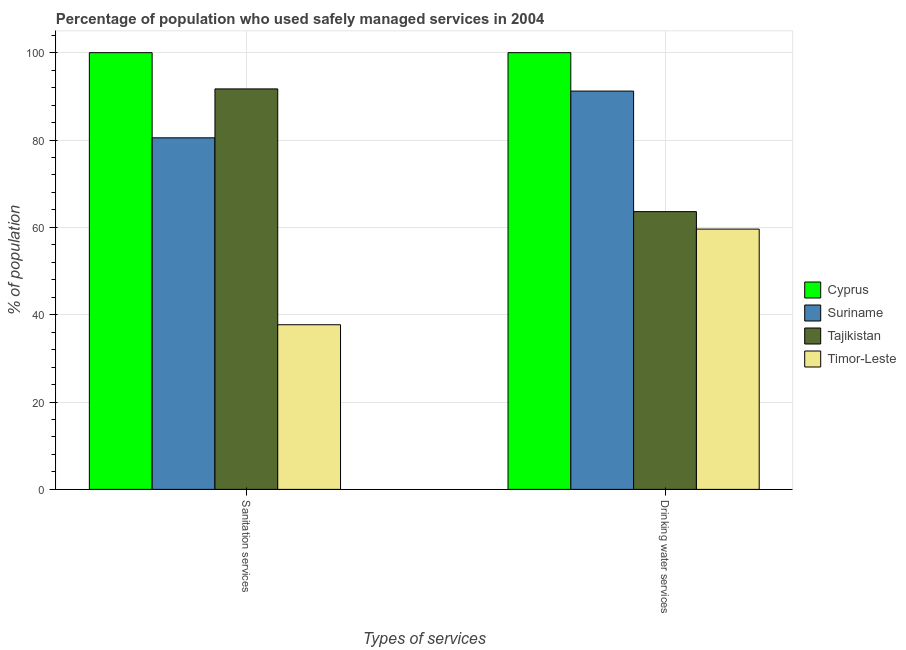How many groups of bars are there?
Your answer should be very brief. 2. Are the number of bars on each tick of the X-axis equal?
Give a very brief answer. Yes. What is the label of the 1st group of bars from the left?
Offer a terse response. Sanitation services. What is the percentage of population who used drinking water services in Timor-Leste?
Offer a terse response. 59.6. Across all countries, what is the minimum percentage of population who used sanitation services?
Make the answer very short. 37.7. In which country was the percentage of population who used drinking water services maximum?
Provide a succinct answer. Cyprus. In which country was the percentage of population who used sanitation services minimum?
Make the answer very short. Timor-Leste. What is the total percentage of population who used drinking water services in the graph?
Offer a terse response. 314.4. What is the difference between the percentage of population who used drinking water services in Tajikistan and that in Suriname?
Your answer should be compact. -27.6. What is the difference between the percentage of population who used sanitation services in Timor-Leste and the percentage of population who used drinking water services in Tajikistan?
Provide a short and direct response. -25.9. What is the average percentage of population who used drinking water services per country?
Your answer should be compact. 78.6. What is the difference between the percentage of population who used sanitation services and percentage of population who used drinking water services in Timor-Leste?
Your answer should be very brief. -21.9. In how many countries, is the percentage of population who used sanitation services greater than 12 %?
Make the answer very short. 4. What is the ratio of the percentage of population who used drinking water services in Tajikistan to that in Suriname?
Offer a terse response. 0.7. What does the 1st bar from the left in Drinking water services represents?
Ensure brevity in your answer.  Cyprus. What does the 1st bar from the right in Sanitation services represents?
Your answer should be compact. Timor-Leste. How many bars are there?
Your response must be concise. 8. How many countries are there in the graph?
Your answer should be very brief. 4. What is the difference between two consecutive major ticks on the Y-axis?
Your answer should be compact. 20. Are the values on the major ticks of Y-axis written in scientific E-notation?
Your answer should be compact. No. How many legend labels are there?
Offer a very short reply. 4. What is the title of the graph?
Ensure brevity in your answer.  Percentage of population who used safely managed services in 2004. What is the label or title of the X-axis?
Your answer should be very brief. Types of services. What is the label or title of the Y-axis?
Keep it short and to the point. % of population. What is the % of population of Cyprus in Sanitation services?
Give a very brief answer. 100. What is the % of population of Suriname in Sanitation services?
Your response must be concise. 80.5. What is the % of population in Tajikistan in Sanitation services?
Provide a succinct answer. 91.7. What is the % of population in Timor-Leste in Sanitation services?
Offer a very short reply. 37.7. What is the % of population of Cyprus in Drinking water services?
Keep it short and to the point. 100. What is the % of population of Suriname in Drinking water services?
Offer a terse response. 91.2. What is the % of population of Tajikistan in Drinking water services?
Make the answer very short. 63.6. What is the % of population of Timor-Leste in Drinking water services?
Offer a very short reply. 59.6. Across all Types of services, what is the maximum % of population in Suriname?
Your answer should be very brief. 91.2. Across all Types of services, what is the maximum % of population in Tajikistan?
Ensure brevity in your answer.  91.7. Across all Types of services, what is the maximum % of population of Timor-Leste?
Provide a short and direct response. 59.6. Across all Types of services, what is the minimum % of population of Cyprus?
Keep it short and to the point. 100. Across all Types of services, what is the minimum % of population of Suriname?
Make the answer very short. 80.5. Across all Types of services, what is the minimum % of population of Tajikistan?
Make the answer very short. 63.6. Across all Types of services, what is the minimum % of population in Timor-Leste?
Ensure brevity in your answer.  37.7. What is the total % of population of Cyprus in the graph?
Provide a succinct answer. 200. What is the total % of population in Suriname in the graph?
Offer a very short reply. 171.7. What is the total % of population of Tajikistan in the graph?
Ensure brevity in your answer.  155.3. What is the total % of population in Timor-Leste in the graph?
Offer a terse response. 97.3. What is the difference between the % of population in Cyprus in Sanitation services and that in Drinking water services?
Your response must be concise. 0. What is the difference between the % of population in Tajikistan in Sanitation services and that in Drinking water services?
Your response must be concise. 28.1. What is the difference between the % of population in Timor-Leste in Sanitation services and that in Drinking water services?
Keep it short and to the point. -21.9. What is the difference between the % of population of Cyprus in Sanitation services and the % of population of Tajikistan in Drinking water services?
Your answer should be very brief. 36.4. What is the difference between the % of population in Cyprus in Sanitation services and the % of population in Timor-Leste in Drinking water services?
Keep it short and to the point. 40.4. What is the difference between the % of population in Suriname in Sanitation services and the % of population in Timor-Leste in Drinking water services?
Make the answer very short. 20.9. What is the difference between the % of population of Tajikistan in Sanitation services and the % of population of Timor-Leste in Drinking water services?
Your answer should be very brief. 32.1. What is the average % of population in Cyprus per Types of services?
Your response must be concise. 100. What is the average % of population in Suriname per Types of services?
Provide a short and direct response. 85.85. What is the average % of population of Tajikistan per Types of services?
Give a very brief answer. 77.65. What is the average % of population of Timor-Leste per Types of services?
Offer a very short reply. 48.65. What is the difference between the % of population in Cyprus and % of population in Tajikistan in Sanitation services?
Offer a terse response. 8.3. What is the difference between the % of population of Cyprus and % of population of Timor-Leste in Sanitation services?
Your answer should be compact. 62.3. What is the difference between the % of population of Suriname and % of population of Timor-Leste in Sanitation services?
Make the answer very short. 42.8. What is the difference between the % of population in Tajikistan and % of population in Timor-Leste in Sanitation services?
Provide a succinct answer. 54. What is the difference between the % of population of Cyprus and % of population of Tajikistan in Drinking water services?
Make the answer very short. 36.4. What is the difference between the % of population of Cyprus and % of population of Timor-Leste in Drinking water services?
Keep it short and to the point. 40.4. What is the difference between the % of population in Suriname and % of population in Tajikistan in Drinking water services?
Keep it short and to the point. 27.6. What is the difference between the % of population in Suriname and % of population in Timor-Leste in Drinking water services?
Provide a short and direct response. 31.6. What is the difference between the % of population of Tajikistan and % of population of Timor-Leste in Drinking water services?
Your answer should be very brief. 4. What is the ratio of the % of population of Suriname in Sanitation services to that in Drinking water services?
Offer a terse response. 0.88. What is the ratio of the % of population in Tajikistan in Sanitation services to that in Drinking water services?
Keep it short and to the point. 1.44. What is the ratio of the % of population in Timor-Leste in Sanitation services to that in Drinking water services?
Offer a terse response. 0.63. What is the difference between the highest and the second highest % of population of Tajikistan?
Give a very brief answer. 28.1. What is the difference between the highest and the second highest % of population of Timor-Leste?
Your answer should be compact. 21.9. What is the difference between the highest and the lowest % of population of Cyprus?
Offer a very short reply. 0. What is the difference between the highest and the lowest % of population in Suriname?
Your response must be concise. 10.7. What is the difference between the highest and the lowest % of population in Tajikistan?
Provide a succinct answer. 28.1. What is the difference between the highest and the lowest % of population of Timor-Leste?
Your answer should be compact. 21.9. 